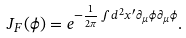Convert formula to latex. <formula><loc_0><loc_0><loc_500><loc_500>J _ { F } ( \phi ) = e ^ { - \frac { 1 } { 2 \pi } \int d ^ { 2 } x ^ { \prime } \partial _ { \mu } \phi \partial _ { \mu } \phi } .</formula> 